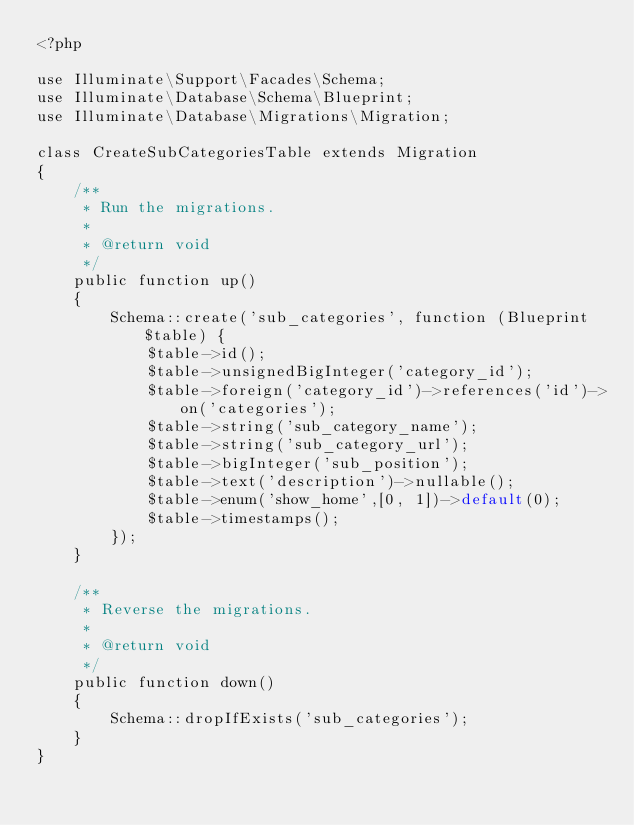<code> <loc_0><loc_0><loc_500><loc_500><_PHP_><?php

use Illuminate\Support\Facades\Schema;
use Illuminate\Database\Schema\Blueprint;
use Illuminate\Database\Migrations\Migration;

class CreateSubCategoriesTable extends Migration
{
    /**
     * Run the migrations.
     *
     * @return void
     */
    public function up()
    {
        Schema::create('sub_categories', function (Blueprint $table) {
            $table->id();
            $table->unsignedBigInteger('category_id');
            $table->foreign('category_id')->references('id')->on('categories');
            $table->string('sub_category_name');
            $table->string('sub_category_url');
            $table->bigInteger('sub_position');
            $table->text('description')->nullable();
            $table->enum('show_home',[0, 1])->default(0);
            $table->timestamps();
        });
    }

    /**
     * Reverse the migrations.
     *
     * @return void
     */
    public function down()
    {
        Schema::dropIfExists('sub_categories');
    }
}
</code> 